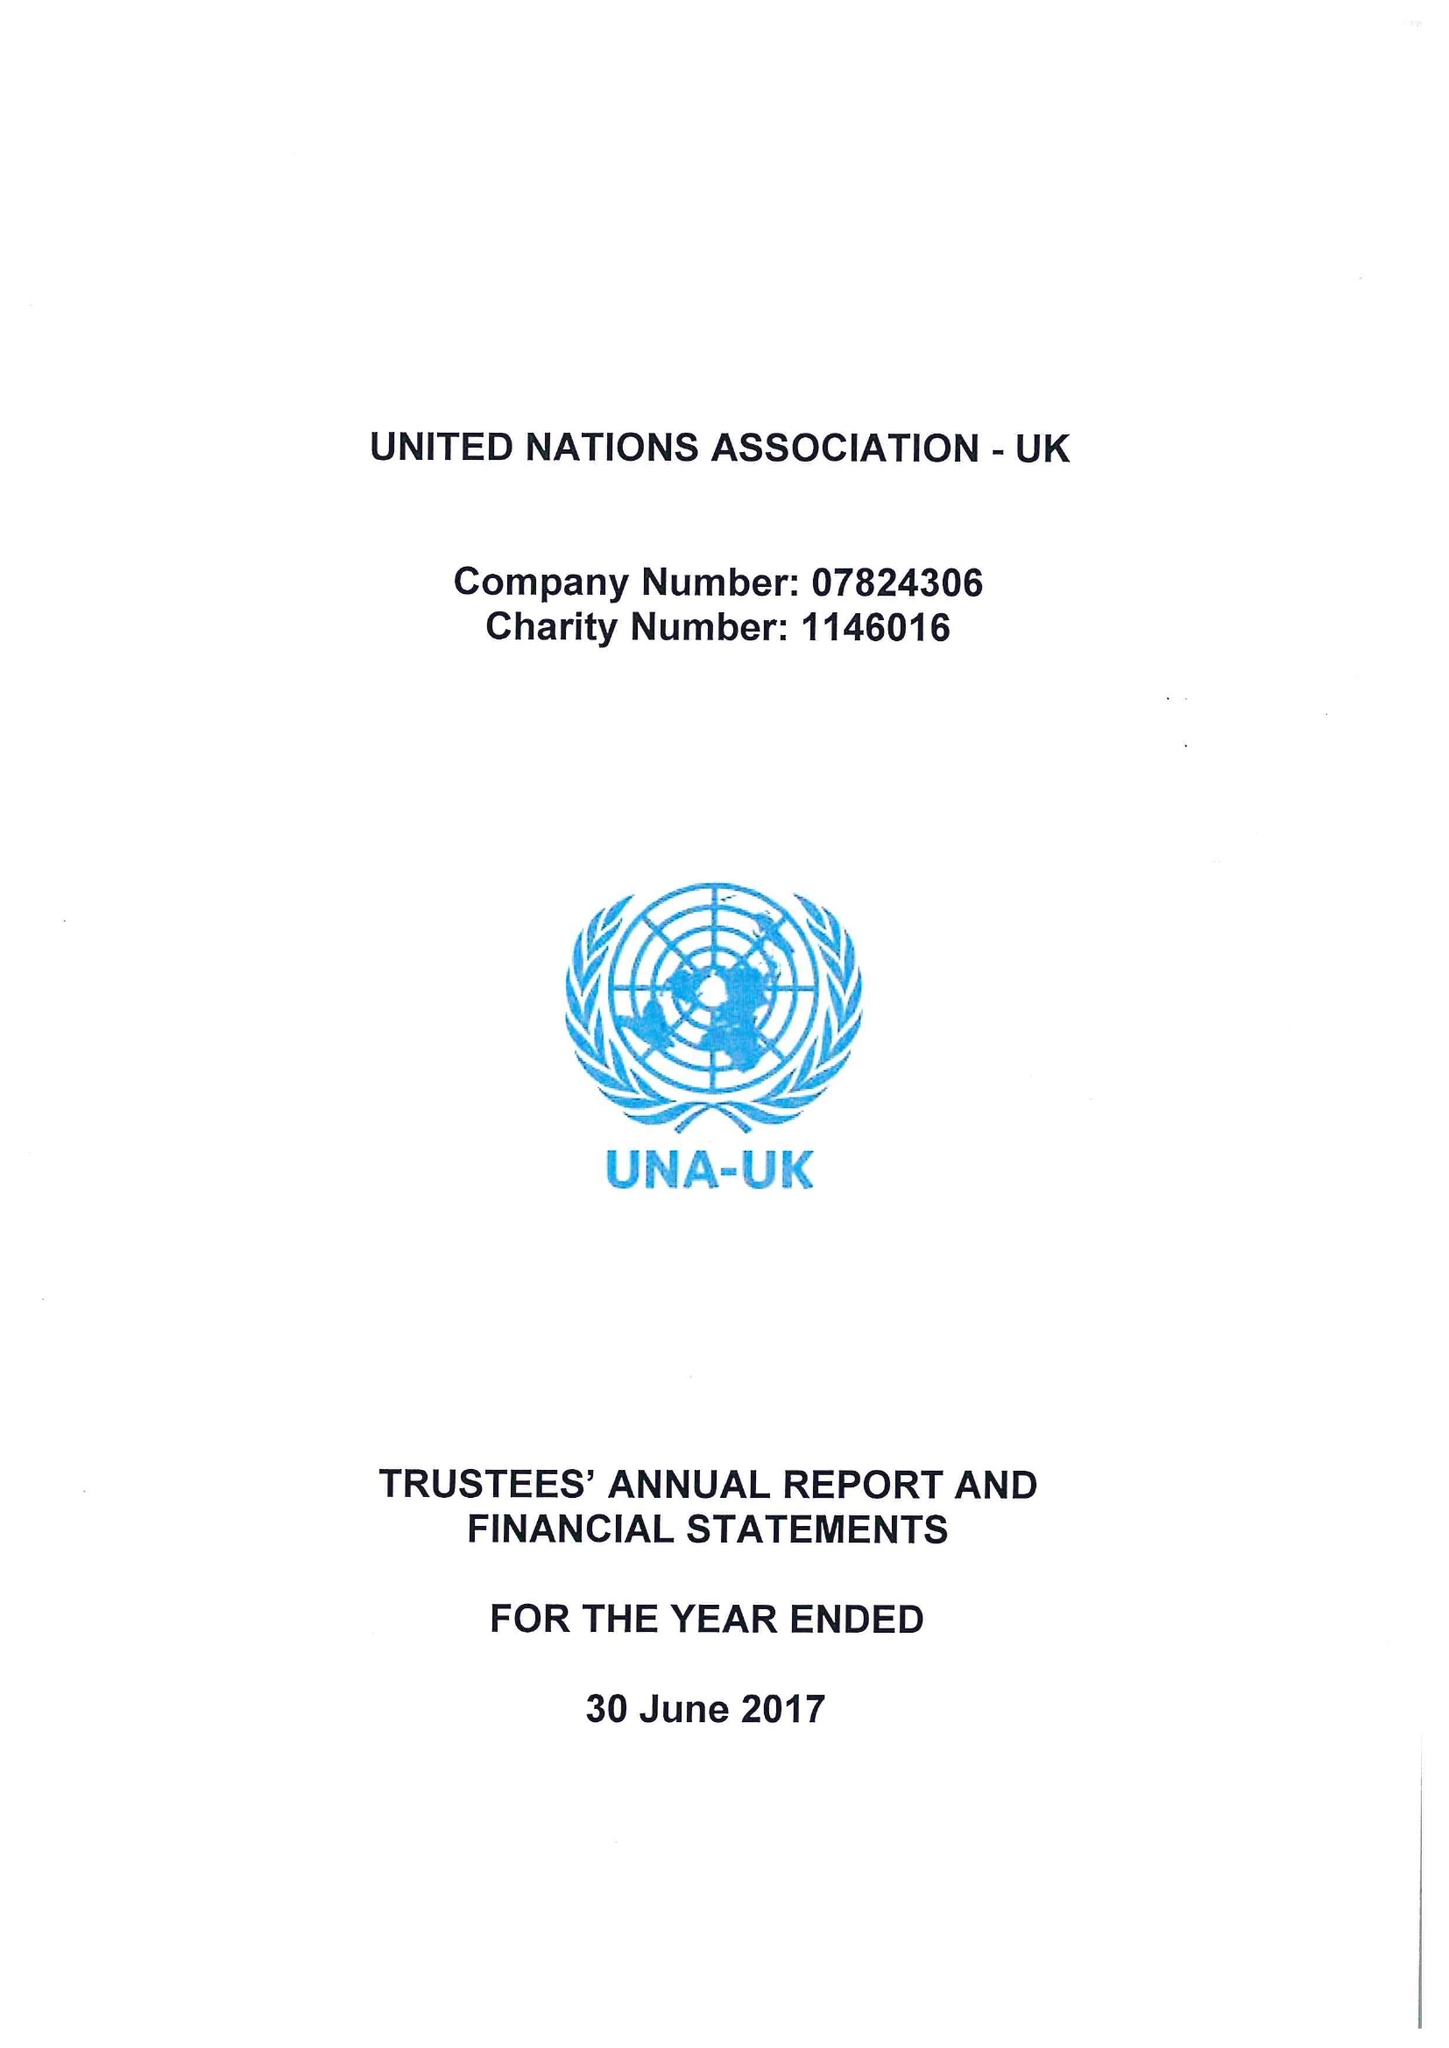What is the value for the address__postcode?
Answer the question using a single word or phrase. SW1A 2EL 